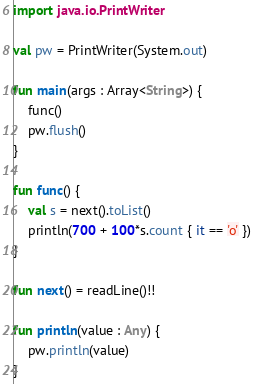<code> <loc_0><loc_0><loc_500><loc_500><_Kotlin_>import java.io.PrintWriter

val pw = PrintWriter(System.out)

fun main(args : Array<String>) {
    func()
    pw.flush()
}

fun func() {
    val s = next().toList()
    println(700 + 100*s.count { it == 'o' })
}

fun next() = readLine()!!

fun println(value : Any) {
    pw.println(value)
}</code> 